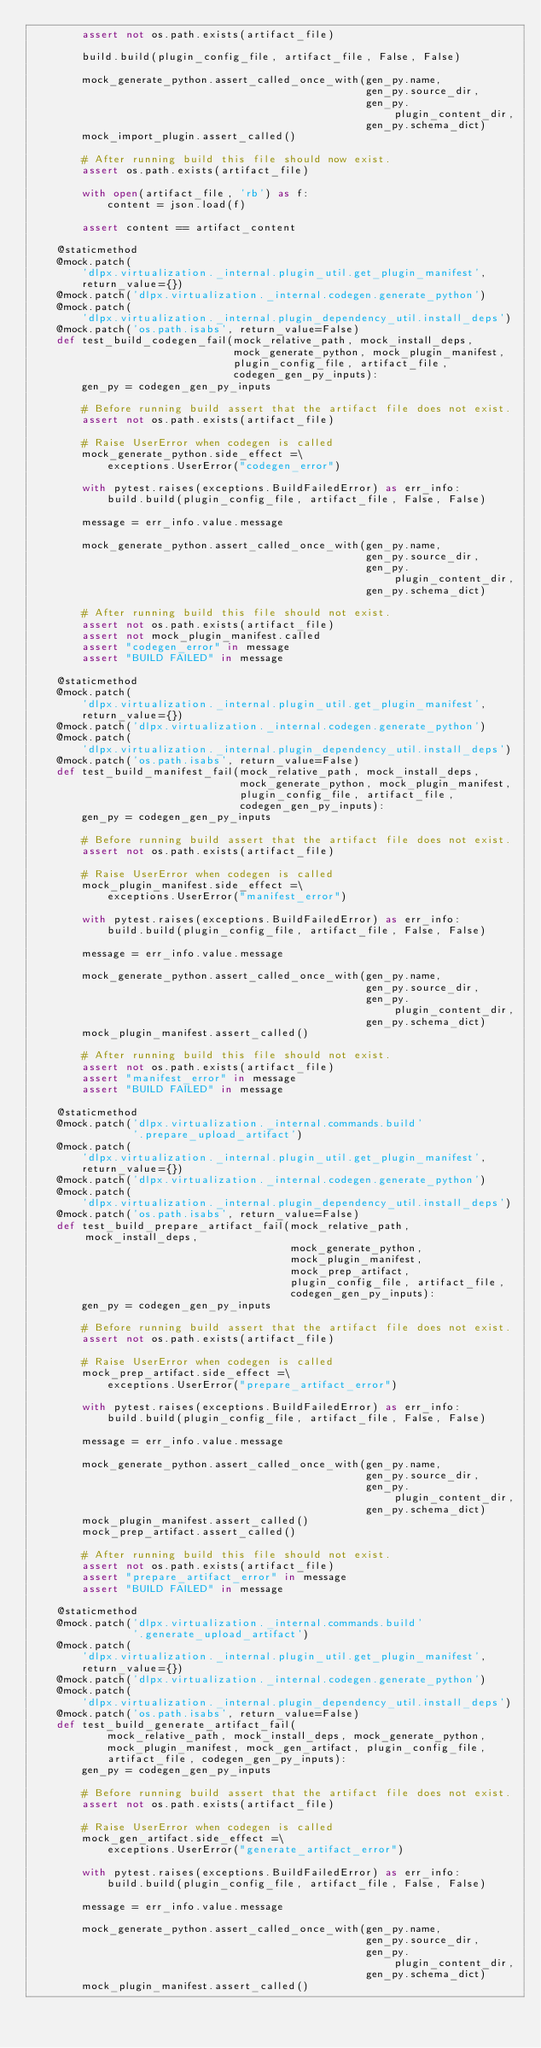Convert code to text. <code><loc_0><loc_0><loc_500><loc_500><_Python_>        assert not os.path.exists(artifact_file)

        build.build(plugin_config_file, artifact_file, False, False)

        mock_generate_python.assert_called_once_with(gen_py.name,
                                                     gen_py.source_dir,
                                                     gen_py.plugin_content_dir,
                                                     gen_py.schema_dict)
        mock_import_plugin.assert_called()

        # After running build this file should now exist.
        assert os.path.exists(artifact_file)

        with open(artifact_file, 'rb') as f:
            content = json.load(f)

        assert content == artifact_content

    @staticmethod
    @mock.patch(
        'dlpx.virtualization._internal.plugin_util.get_plugin_manifest',
        return_value={})
    @mock.patch('dlpx.virtualization._internal.codegen.generate_python')
    @mock.patch(
        'dlpx.virtualization._internal.plugin_dependency_util.install_deps')
    @mock.patch('os.path.isabs', return_value=False)
    def test_build_codegen_fail(mock_relative_path, mock_install_deps,
                                mock_generate_python, mock_plugin_manifest,
                                plugin_config_file, artifact_file,
                                codegen_gen_py_inputs):
        gen_py = codegen_gen_py_inputs

        # Before running build assert that the artifact file does not exist.
        assert not os.path.exists(artifact_file)

        # Raise UserError when codegen is called
        mock_generate_python.side_effect =\
            exceptions.UserError("codegen_error")

        with pytest.raises(exceptions.BuildFailedError) as err_info:
            build.build(plugin_config_file, artifact_file, False, False)

        message = err_info.value.message

        mock_generate_python.assert_called_once_with(gen_py.name,
                                                     gen_py.source_dir,
                                                     gen_py.plugin_content_dir,
                                                     gen_py.schema_dict)

        # After running build this file should not exist.
        assert not os.path.exists(artifact_file)
        assert not mock_plugin_manifest.called
        assert "codegen_error" in message
        assert "BUILD FAILED" in message

    @staticmethod
    @mock.patch(
        'dlpx.virtualization._internal.plugin_util.get_plugin_manifest',
        return_value={})
    @mock.patch('dlpx.virtualization._internal.codegen.generate_python')
    @mock.patch(
        'dlpx.virtualization._internal.plugin_dependency_util.install_deps')
    @mock.patch('os.path.isabs', return_value=False)
    def test_build_manifest_fail(mock_relative_path, mock_install_deps,
                                 mock_generate_python, mock_plugin_manifest,
                                 plugin_config_file, artifact_file,
                                 codegen_gen_py_inputs):
        gen_py = codegen_gen_py_inputs

        # Before running build assert that the artifact file does not exist.
        assert not os.path.exists(artifact_file)

        # Raise UserError when codegen is called
        mock_plugin_manifest.side_effect =\
            exceptions.UserError("manifest_error")

        with pytest.raises(exceptions.BuildFailedError) as err_info:
            build.build(plugin_config_file, artifact_file, False, False)

        message = err_info.value.message

        mock_generate_python.assert_called_once_with(gen_py.name,
                                                     gen_py.source_dir,
                                                     gen_py.plugin_content_dir,
                                                     gen_py.schema_dict)
        mock_plugin_manifest.assert_called()

        # After running build this file should not exist.
        assert not os.path.exists(artifact_file)
        assert "manifest_error" in message
        assert "BUILD FAILED" in message

    @staticmethod
    @mock.patch('dlpx.virtualization._internal.commands.build'
                '.prepare_upload_artifact')
    @mock.patch(
        'dlpx.virtualization._internal.plugin_util.get_plugin_manifest',
        return_value={})
    @mock.patch('dlpx.virtualization._internal.codegen.generate_python')
    @mock.patch(
        'dlpx.virtualization._internal.plugin_dependency_util.install_deps')
    @mock.patch('os.path.isabs', return_value=False)
    def test_build_prepare_artifact_fail(mock_relative_path, mock_install_deps,
                                         mock_generate_python,
                                         mock_plugin_manifest,
                                         mock_prep_artifact,
                                         plugin_config_file, artifact_file,
                                         codegen_gen_py_inputs):
        gen_py = codegen_gen_py_inputs

        # Before running build assert that the artifact file does not exist.
        assert not os.path.exists(artifact_file)

        # Raise UserError when codegen is called
        mock_prep_artifact.side_effect =\
            exceptions.UserError("prepare_artifact_error")

        with pytest.raises(exceptions.BuildFailedError) as err_info:
            build.build(plugin_config_file, artifact_file, False, False)

        message = err_info.value.message

        mock_generate_python.assert_called_once_with(gen_py.name,
                                                     gen_py.source_dir,
                                                     gen_py.plugin_content_dir,
                                                     gen_py.schema_dict)
        mock_plugin_manifest.assert_called()
        mock_prep_artifact.assert_called()

        # After running build this file should not exist.
        assert not os.path.exists(artifact_file)
        assert "prepare_artifact_error" in message
        assert "BUILD FAILED" in message

    @staticmethod
    @mock.patch('dlpx.virtualization._internal.commands.build'
                '.generate_upload_artifact')
    @mock.patch(
        'dlpx.virtualization._internal.plugin_util.get_plugin_manifest',
        return_value={})
    @mock.patch('dlpx.virtualization._internal.codegen.generate_python')
    @mock.patch(
        'dlpx.virtualization._internal.plugin_dependency_util.install_deps')
    @mock.patch('os.path.isabs', return_value=False)
    def test_build_generate_artifact_fail(
            mock_relative_path, mock_install_deps, mock_generate_python,
            mock_plugin_manifest, mock_gen_artifact, plugin_config_file,
            artifact_file, codegen_gen_py_inputs):
        gen_py = codegen_gen_py_inputs

        # Before running build assert that the artifact file does not exist.
        assert not os.path.exists(artifact_file)

        # Raise UserError when codegen is called
        mock_gen_artifact.side_effect =\
            exceptions.UserError("generate_artifact_error")

        with pytest.raises(exceptions.BuildFailedError) as err_info:
            build.build(plugin_config_file, artifact_file, False, False)

        message = err_info.value.message

        mock_generate_python.assert_called_once_with(gen_py.name,
                                                     gen_py.source_dir,
                                                     gen_py.plugin_content_dir,
                                                     gen_py.schema_dict)
        mock_plugin_manifest.assert_called()</code> 